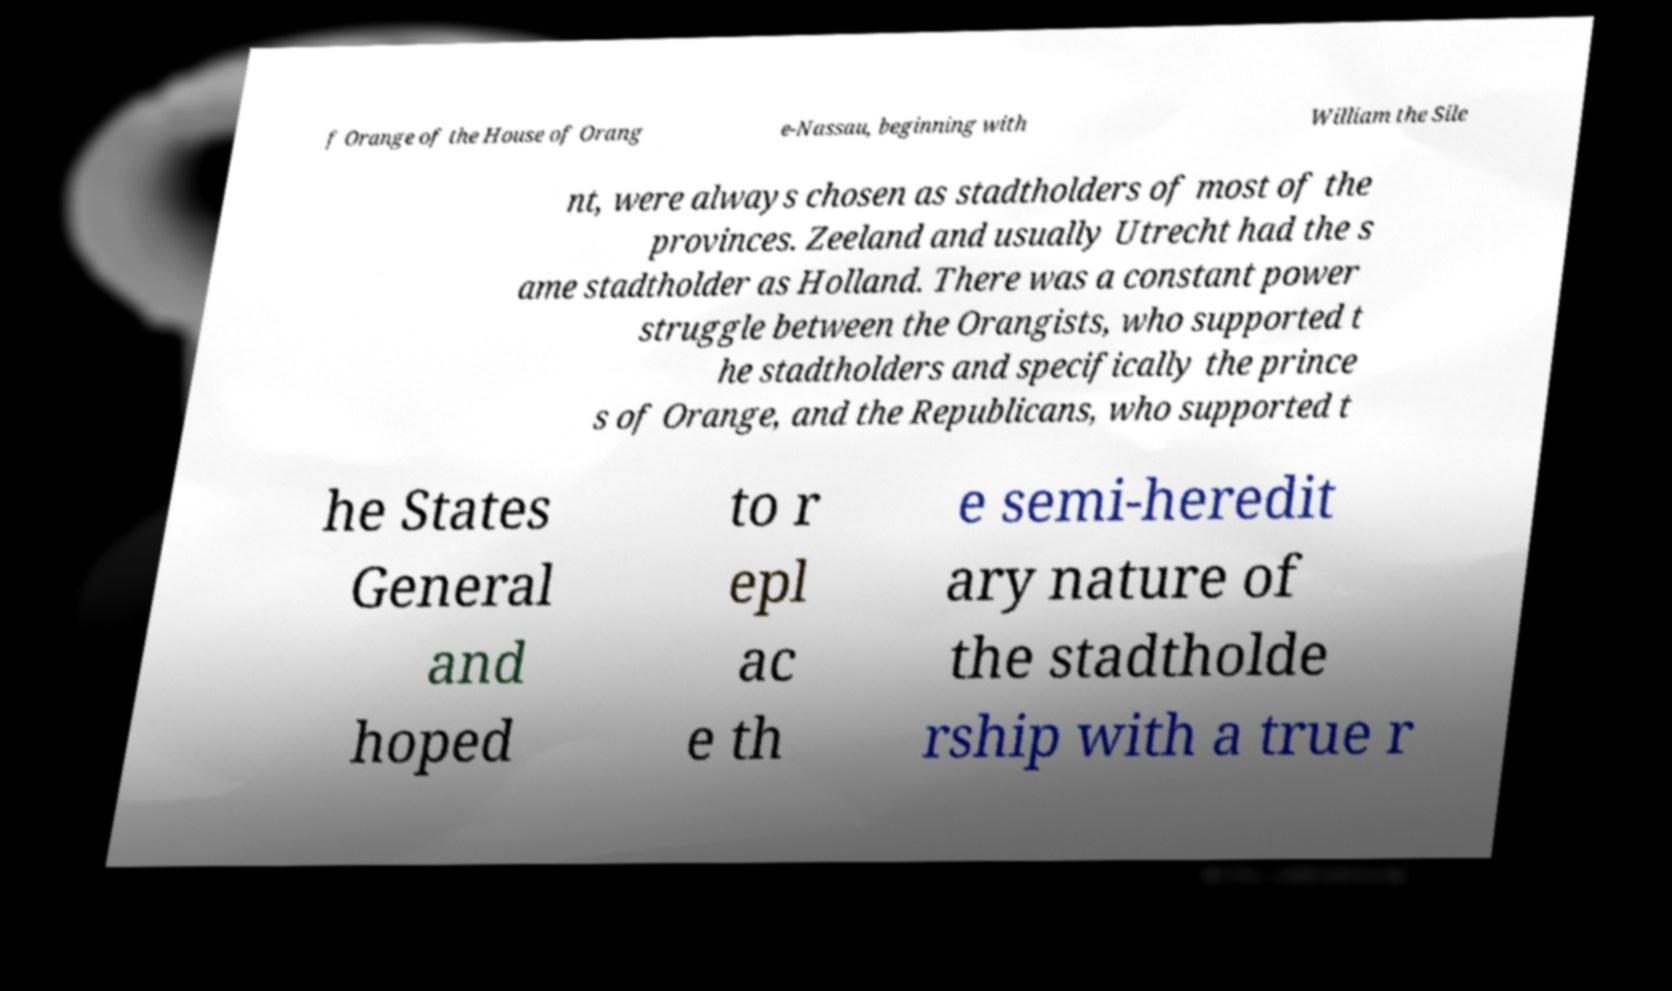Could you extract and type out the text from this image? f Orange of the House of Orang e-Nassau, beginning with William the Sile nt, were always chosen as stadtholders of most of the provinces. Zeeland and usually Utrecht had the s ame stadtholder as Holland. There was a constant power struggle between the Orangists, who supported t he stadtholders and specifically the prince s of Orange, and the Republicans, who supported t he States General and hoped to r epl ac e th e semi-heredit ary nature of the stadtholde rship with a true r 